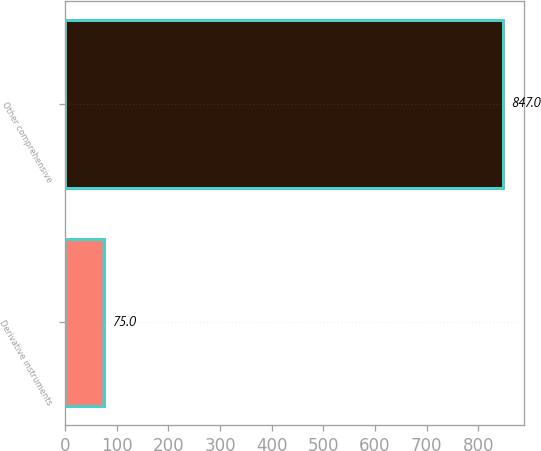Convert chart. <chart><loc_0><loc_0><loc_500><loc_500><bar_chart><fcel>Derivative instruments<fcel>Other comprehensive<nl><fcel>75<fcel>847<nl></chart> 